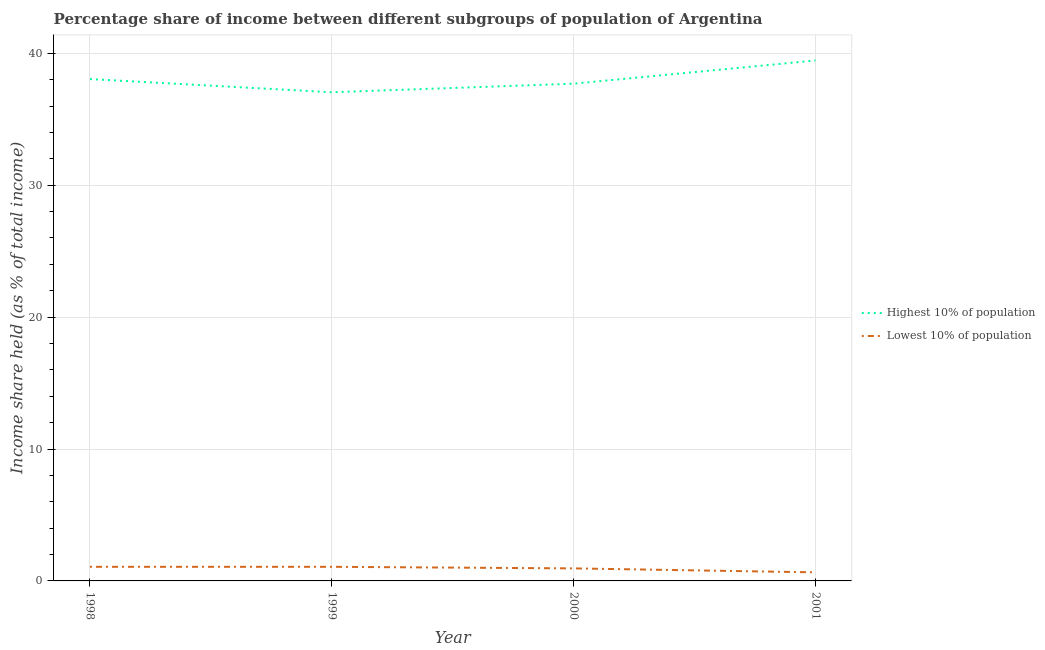How many different coloured lines are there?
Provide a short and direct response. 2. Does the line corresponding to income share held by highest 10% of the population intersect with the line corresponding to income share held by lowest 10% of the population?
Make the answer very short. No. What is the income share held by lowest 10% of the population in 1999?
Your response must be concise. 1.07. Across all years, what is the maximum income share held by lowest 10% of the population?
Offer a very short reply. 1.07. Across all years, what is the minimum income share held by lowest 10% of the population?
Keep it short and to the point. 0.65. In which year was the income share held by highest 10% of the population maximum?
Your answer should be very brief. 2001. In which year was the income share held by highest 10% of the population minimum?
Keep it short and to the point. 1999. What is the total income share held by lowest 10% of the population in the graph?
Your response must be concise. 3.74. What is the difference between the income share held by highest 10% of the population in 1999 and that in 2001?
Make the answer very short. -2.41. What is the difference between the income share held by lowest 10% of the population in 1998 and the income share held by highest 10% of the population in 2000?
Ensure brevity in your answer.  -36.63. What is the average income share held by highest 10% of the population per year?
Your answer should be very brief. 38.06. In the year 1998, what is the difference between the income share held by lowest 10% of the population and income share held by highest 10% of the population?
Offer a very short reply. -36.98. In how many years, is the income share held by lowest 10% of the population greater than 22 %?
Keep it short and to the point. 0. What is the ratio of the income share held by lowest 10% of the population in 1998 to that in 1999?
Keep it short and to the point. 1. Is the income share held by lowest 10% of the population in 1999 less than that in 2000?
Offer a very short reply. No. Is the difference between the income share held by highest 10% of the population in 1999 and 2000 greater than the difference between the income share held by lowest 10% of the population in 1999 and 2000?
Your answer should be very brief. No. What is the difference between the highest and the second highest income share held by highest 10% of the population?
Your answer should be very brief. 1.41. What is the difference between the highest and the lowest income share held by lowest 10% of the population?
Offer a very short reply. 0.42. In how many years, is the income share held by lowest 10% of the population greater than the average income share held by lowest 10% of the population taken over all years?
Offer a terse response. 3. Is the sum of the income share held by lowest 10% of the population in 1998 and 2000 greater than the maximum income share held by highest 10% of the population across all years?
Make the answer very short. No. Is the income share held by lowest 10% of the population strictly less than the income share held by highest 10% of the population over the years?
Your response must be concise. Yes. How many lines are there?
Keep it short and to the point. 2. What is the difference between two consecutive major ticks on the Y-axis?
Ensure brevity in your answer.  10. Does the graph contain grids?
Give a very brief answer. Yes. How many legend labels are there?
Provide a short and direct response. 2. How are the legend labels stacked?
Provide a short and direct response. Vertical. What is the title of the graph?
Offer a very short reply. Percentage share of income between different subgroups of population of Argentina. Does "Borrowers" appear as one of the legend labels in the graph?
Offer a terse response. No. What is the label or title of the Y-axis?
Provide a succinct answer. Income share held (as % of total income). What is the Income share held (as % of total income) in Highest 10% of population in 1998?
Provide a succinct answer. 38.05. What is the Income share held (as % of total income) of Lowest 10% of population in 1998?
Give a very brief answer. 1.07. What is the Income share held (as % of total income) in Highest 10% of population in 1999?
Your response must be concise. 37.05. What is the Income share held (as % of total income) in Lowest 10% of population in 1999?
Provide a succinct answer. 1.07. What is the Income share held (as % of total income) of Highest 10% of population in 2000?
Offer a terse response. 37.7. What is the Income share held (as % of total income) of Lowest 10% of population in 2000?
Offer a very short reply. 0.95. What is the Income share held (as % of total income) of Highest 10% of population in 2001?
Your answer should be very brief. 39.46. What is the Income share held (as % of total income) in Lowest 10% of population in 2001?
Ensure brevity in your answer.  0.65. Across all years, what is the maximum Income share held (as % of total income) of Highest 10% of population?
Your answer should be very brief. 39.46. Across all years, what is the maximum Income share held (as % of total income) in Lowest 10% of population?
Provide a short and direct response. 1.07. Across all years, what is the minimum Income share held (as % of total income) of Highest 10% of population?
Your response must be concise. 37.05. Across all years, what is the minimum Income share held (as % of total income) in Lowest 10% of population?
Make the answer very short. 0.65. What is the total Income share held (as % of total income) in Highest 10% of population in the graph?
Your response must be concise. 152.26. What is the total Income share held (as % of total income) in Lowest 10% of population in the graph?
Ensure brevity in your answer.  3.74. What is the difference between the Income share held (as % of total income) in Highest 10% of population in 1998 and that in 1999?
Make the answer very short. 1. What is the difference between the Income share held (as % of total income) in Highest 10% of population in 1998 and that in 2000?
Your response must be concise. 0.35. What is the difference between the Income share held (as % of total income) in Lowest 10% of population in 1998 and that in 2000?
Offer a very short reply. 0.12. What is the difference between the Income share held (as % of total income) in Highest 10% of population in 1998 and that in 2001?
Provide a short and direct response. -1.41. What is the difference between the Income share held (as % of total income) of Lowest 10% of population in 1998 and that in 2001?
Your response must be concise. 0.42. What is the difference between the Income share held (as % of total income) in Highest 10% of population in 1999 and that in 2000?
Make the answer very short. -0.65. What is the difference between the Income share held (as % of total income) of Lowest 10% of population in 1999 and that in 2000?
Your answer should be compact. 0.12. What is the difference between the Income share held (as % of total income) of Highest 10% of population in 1999 and that in 2001?
Offer a terse response. -2.41. What is the difference between the Income share held (as % of total income) of Lowest 10% of population in 1999 and that in 2001?
Your response must be concise. 0.42. What is the difference between the Income share held (as % of total income) in Highest 10% of population in 2000 and that in 2001?
Give a very brief answer. -1.76. What is the difference between the Income share held (as % of total income) in Highest 10% of population in 1998 and the Income share held (as % of total income) in Lowest 10% of population in 1999?
Provide a succinct answer. 36.98. What is the difference between the Income share held (as % of total income) in Highest 10% of population in 1998 and the Income share held (as % of total income) in Lowest 10% of population in 2000?
Make the answer very short. 37.1. What is the difference between the Income share held (as % of total income) in Highest 10% of population in 1998 and the Income share held (as % of total income) in Lowest 10% of population in 2001?
Offer a terse response. 37.4. What is the difference between the Income share held (as % of total income) of Highest 10% of population in 1999 and the Income share held (as % of total income) of Lowest 10% of population in 2000?
Ensure brevity in your answer.  36.1. What is the difference between the Income share held (as % of total income) of Highest 10% of population in 1999 and the Income share held (as % of total income) of Lowest 10% of population in 2001?
Provide a short and direct response. 36.4. What is the difference between the Income share held (as % of total income) in Highest 10% of population in 2000 and the Income share held (as % of total income) in Lowest 10% of population in 2001?
Your answer should be compact. 37.05. What is the average Income share held (as % of total income) of Highest 10% of population per year?
Keep it short and to the point. 38.06. What is the average Income share held (as % of total income) in Lowest 10% of population per year?
Offer a terse response. 0.94. In the year 1998, what is the difference between the Income share held (as % of total income) of Highest 10% of population and Income share held (as % of total income) of Lowest 10% of population?
Your answer should be very brief. 36.98. In the year 1999, what is the difference between the Income share held (as % of total income) in Highest 10% of population and Income share held (as % of total income) in Lowest 10% of population?
Provide a succinct answer. 35.98. In the year 2000, what is the difference between the Income share held (as % of total income) of Highest 10% of population and Income share held (as % of total income) of Lowest 10% of population?
Offer a terse response. 36.75. In the year 2001, what is the difference between the Income share held (as % of total income) of Highest 10% of population and Income share held (as % of total income) of Lowest 10% of population?
Keep it short and to the point. 38.81. What is the ratio of the Income share held (as % of total income) of Lowest 10% of population in 1998 to that in 1999?
Your answer should be compact. 1. What is the ratio of the Income share held (as % of total income) in Highest 10% of population in 1998 to that in 2000?
Your answer should be compact. 1.01. What is the ratio of the Income share held (as % of total income) of Lowest 10% of population in 1998 to that in 2000?
Make the answer very short. 1.13. What is the ratio of the Income share held (as % of total income) in Highest 10% of population in 1998 to that in 2001?
Provide a succinct answer. 0.96. What is the ratio of the Income share held (as % of total income) in Lowest 10% of population in 1998 to that in 2001?
Offer a very short reply. 1.65. What is the ratio of the Income share held (as % of total income) of Highest 10% of population in 1999 to that in 2000?
Keep it short and to the point. 0.98. What is the ratio of the Income share held (as % of total income) in Lowest 10% of population in 1999 to that in 2000?
Provide a succinct answer. 1.13. What is the ratio of the Income share held (as % of total income) in Highest 10% of population in 1999 to that in 2001?
Give a very brief answer. 0.94. What is the ratio of the Income share held (as % of total income) in Lowest 10% of population in 1999 to that in 2001?
Give a very brief answer. 1.65. What is the ratio of the Income share held (as % of total income) in Highest 10% of population in 2000 to that in 2001?
Your answer should be compact. 0.96. What is the ratio of the Income share held (as % of total income) in Lowest 10% of population in 2000 to that in 2001?
Make the answer very short. 1.46. What is the difference between the highest and the second highest Income share held (as % of total income) in Highest 10% of population?
Make the answer very short. 1.41. What is the difference between the highest and the second highest Income share held (as % of total income) of Lowest 10% of population?
Provide a short and direct response. 0. What is the difference between the highest and the lowest Income share held (as % of total income) in Highest 10% of population?
Provide a succinct answer. 2.41. What is the difference between the highest and the lowest Income share held (as % of total income) in Lowest 10% of population?
Offer a terse response. 0.42. 